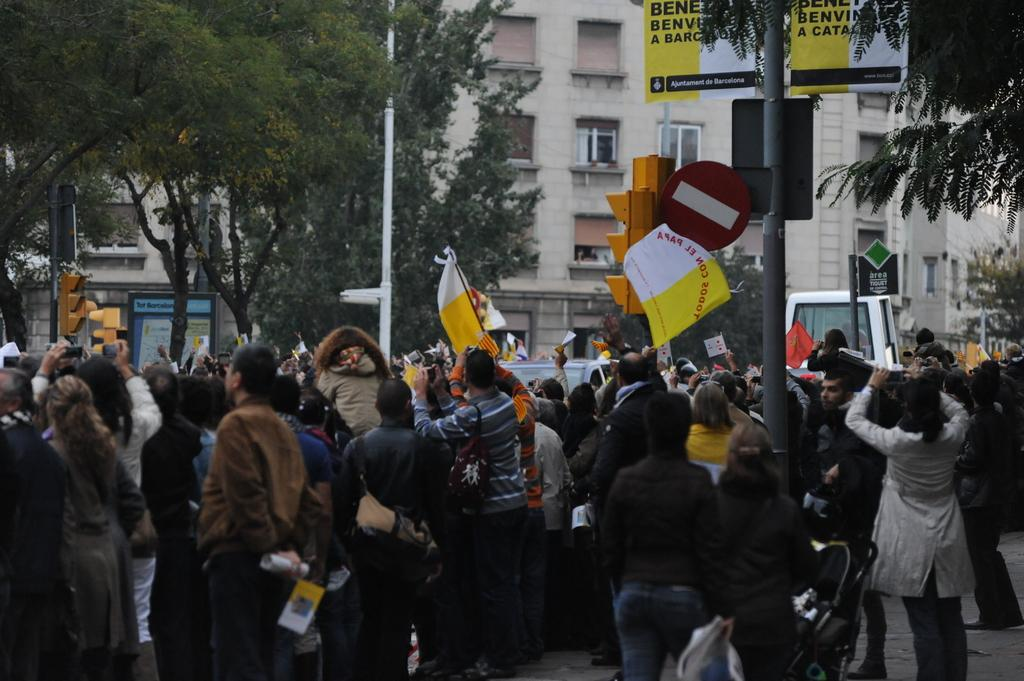What can be seen in the foreground of the picture? There are people, flags, and vehicles in the foreground of the picture. What is visible in the background of the picture? There are trees, buildings, and poles in the background of the picture. How many elements are present in the foreground of the picture? There are three elements present in the foreground: people, flags, and vehicles. What type of structures can be seen in the background of the picture? There are buildings visible in the background of the picture. What type of clock is visible in the picture? There is no clock present in the picture. How does the behavior of the people in the picture affect the vehicles? The provided facts do not mention any specific behavior of the people, so it is impossible to determine how their behavior affects the vehicles. 